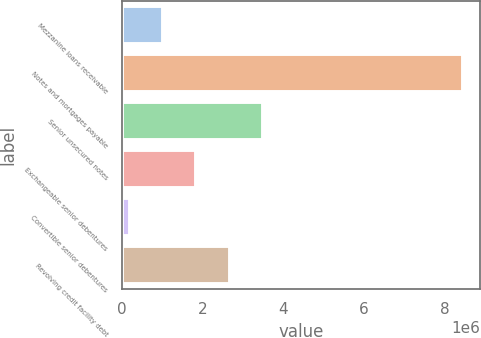Convert chart. <chart><loc_0><loc_0><loc_500><loc_500><bar_chart><fcel>Mezzanine loans receivable<fcel>Notes and mortgages payable<fcel>Senior unsecured notes<fcel>Exchangeable senior debentures<fcel>Convertible senior debentures<fcel>Revolving credit facility debt<nl><fcel>1.01704e+06<fcel>8.44679e+06<fcel>3.49362e+06<fcel>1.84257e+06<fcel>191510<fcel>2.66809e+06<nl></chart> 